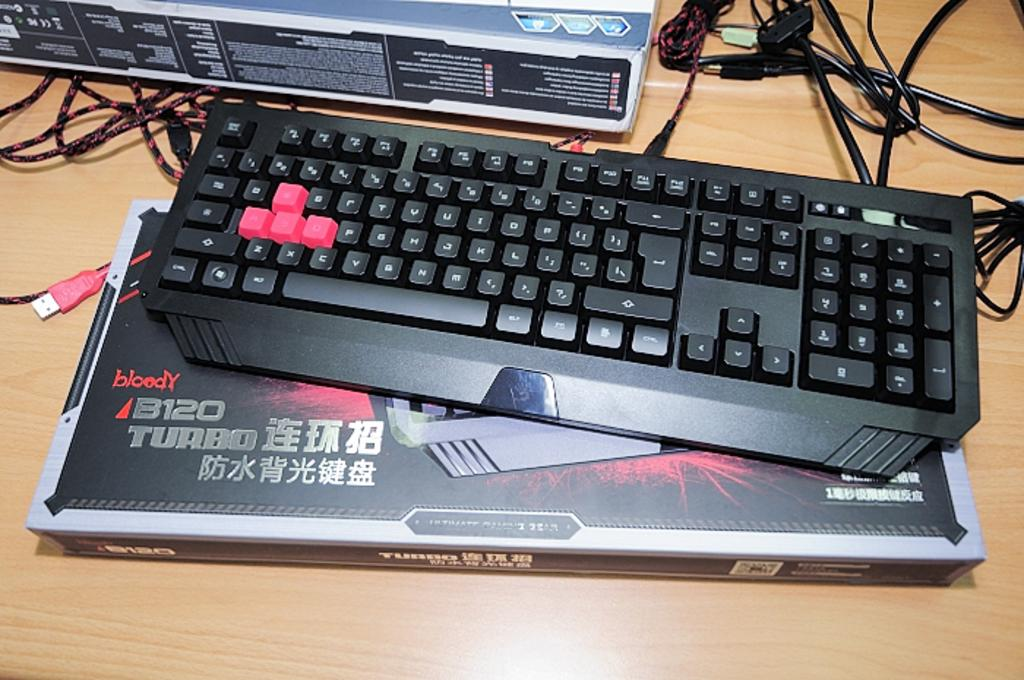<image>
Summarize the visual content of the image. Keyboard that is chinese with turbo and the box 